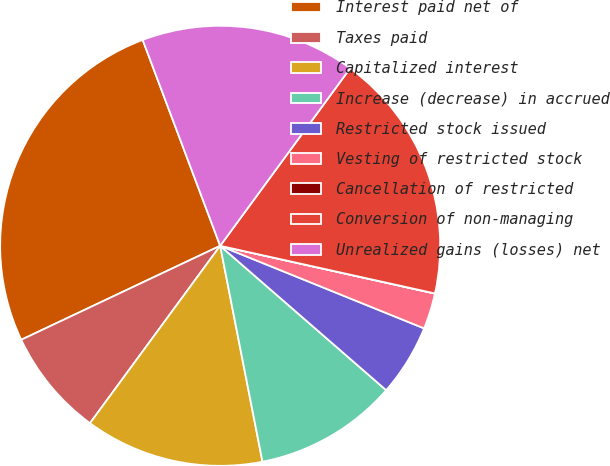Convert chart. <chart><loc_0><loc_0><loc_500><loc_500><pie_chart><fcel>Interest paid net of<fcel>Taxes paid<fcel>Capitalized interest<fcel>Increase (decrease) in accrued<fcel>Restricted stock issued<fcel>Vesting of restricted stock<fcel>Cancellation of restricted<fcel>Conversion of non-managing<fcel>Unrealized gains (losses) net<nl><fcel>26.3%<fcel>7.9%<fcel>13.16%<fcel>10.53%<fcel>5.27%<fcel>2.64%<fcel>0.01%<fcel>18.42%<fcel>15.79%<nl></chart> 